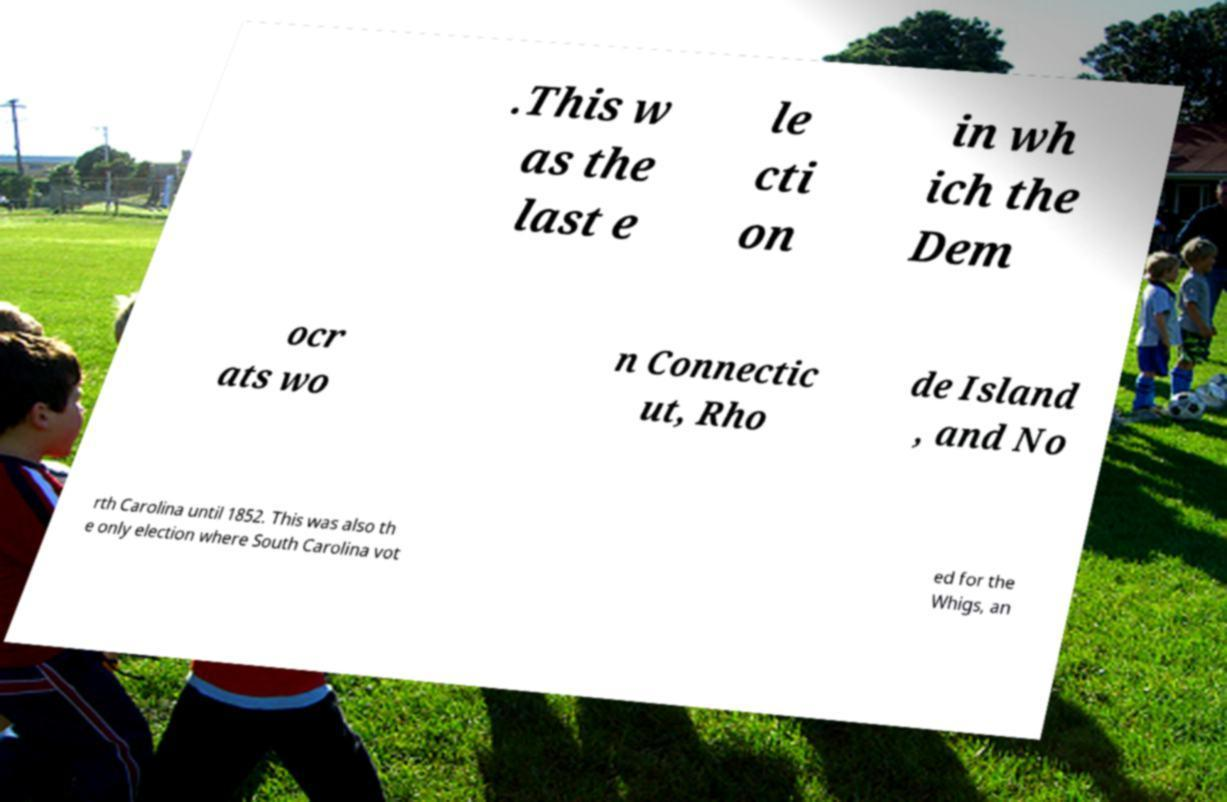I need the written content from this picture converted into text. Can you do that? .This w as the last e le cti on in wh ich the Dem ocr ats wo n Connectic ut, Rho de Island , and No rth Carolina until 1852. This was also th e only election where South Carolina vot ed for the Whigs, an 